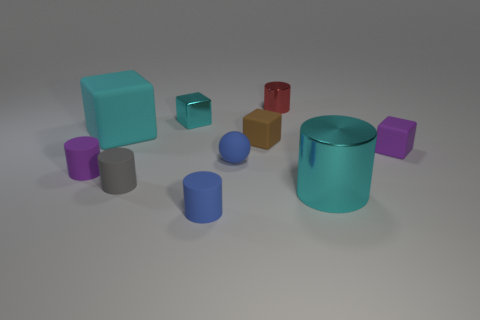Can you describe the shapes and colors of the objects in the image? Certainly! The image showcases a variety of geometric shapes in different colors. There's a large cyan cylinder, a small blue sphere, a purple cube, a red cube, and a small grey cylinder, among others. Overall, it presents a play of solids in an array of pastel and bold colors set against a neutral background. How do the different colors and shapes contribute to the composition of the image? The interplay of colors and shapes creates a visually engaging composition. The cool colors, like cyan and blue, evoke calm and balance, while the red cube adds a pop of energy. Geometric shapes like cylinders, cubes, and spheres introduce structural variety, making the scene dynamic yet harmonious. 